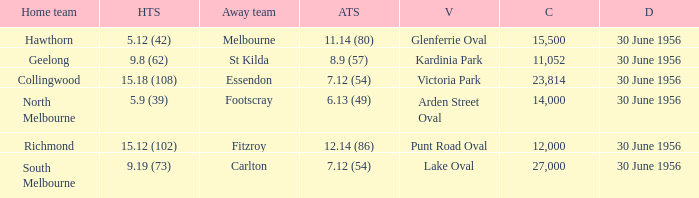What is the home team for punt road oval? Richmond. 